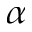<formula> <loc_0><loc_0><loc_500><loc_500>\alpha</formula> 